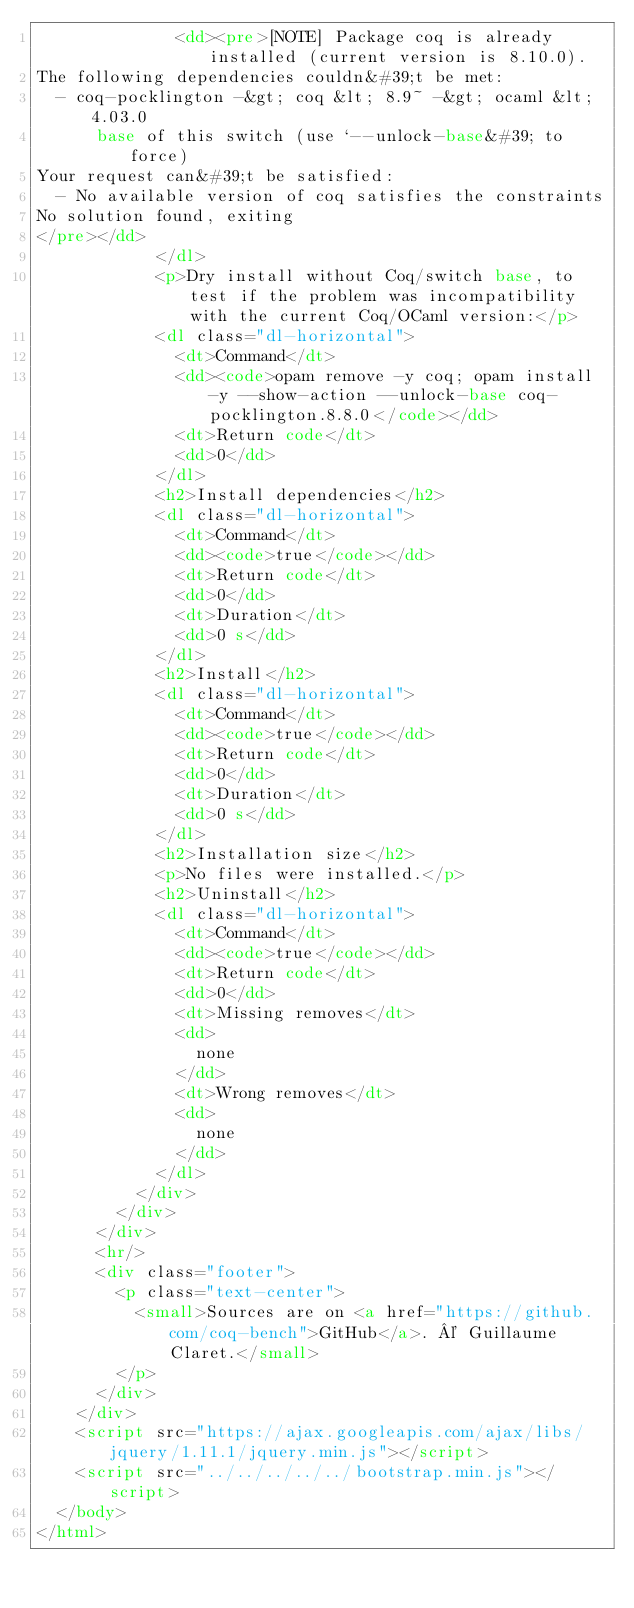<code> <loc_0><loc_0><loc_500><loc_500><_HTML_>              <dd><pre>[NOTE] Package coq is already installed (current version is 8.10.0).
The following dependencies couldn&#39;t be met:
  - coq-pocklington -&gt; coq &lt; 8.9~ -&gt; ocaml &lt; 4.03.0
      base of this switch (use `--unlock-base&#39; to force)
Your request can&#39;t be satisfied:
  - No available version of coq satisfies the constraints
No solution found, exiting
</pre></dd>
            </dl>
            <p>Dry install without Coq/switch base, to test if the problem was incompatibility with the current Coq/OCaml version:</p>
            <dl class="dl-horizontal">
              <dt>Command</dt>
              <dd><code>opam remove -y coq; opam install -y --show-action --unlock-base coq-pocklington.8.8.0</code></dd>
              <dt>Return code</dt>
              <dd>0</dd>
            </dl>
            <h2>Install dependencies</h2>
            <dl class="dl-horizontal">
              <dt>Command</dt>
              <dd><code>true</code></dd>
              <dt>Return code</dt>
              <dd>0</dd>
              <dt>Duration</dt>
              <dd>0 s</dd>
            </dl>
            <h2>Install</h2>
            <dl class="dl-horizontal">
              <dt>Command</dt>
              <dd><code>true</code></dd>
              <dt>Return code</dt>
              <dd>0</dd>
              <dt>Duration</dt>
              <dd>0 s</dd>
            </dl>
            <h2>Installation size</h2>
            <p>No files were installed.</p>
            <h2>Uninstall</h2>
            <dl class="dl-horizontal">
              <dt>Command</dt>
              <dd><code>true</code></dd>
              <dt>Return code</dt>
              <dd>0</dd>
              <dt>Missing removes</dt>
              <dd>
                none
              </dd>
              <dt>Wrong removes</dt>
              <dd>
                none
              </dd>
            </dl>
          </div>
        </div>
      </div>
      <hr/>
      <div class="footer">
        <p class="text-center">
          <small>Sources are on <a href="https://github.com/coq-bench">GitHub</a>. © Guillaume Claret.</small>
        </p>
      </div>
    </div>
    <script src="https://ajax.googleapis.com/ajax/libs/jquery/1.11.1/jquery.min.js"></script>
    <script src="../../../../../bootstrap.min.js"></script>
  </body>
</html>
</code> 